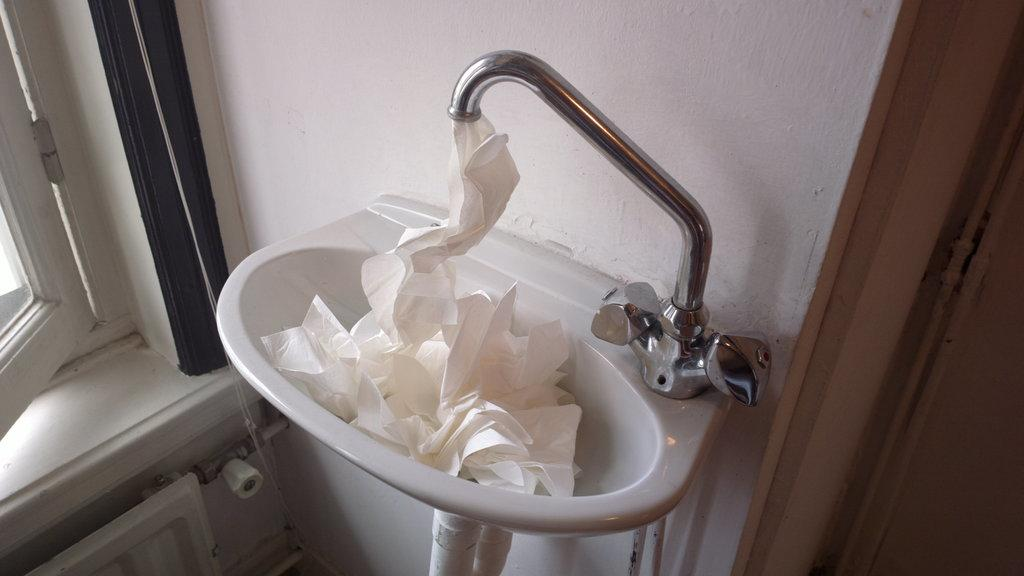What is the main object in the center of the image? There is a sink in the center of the image. What can be seen near the sink? Tissues are visible in the image. Where is the door located in the image? The door is on the right side of the image. What is on the opposite side of the door? There is a window on the left side of the image. What is visible in the background of the image? There is a wall in the background of the image. What type of business is being conducted in the image? There is no indication of a business in the image; it appears to be a room with a sink, door, window, and wall. Can you see a jar in the image? There is no jar present in the image. 